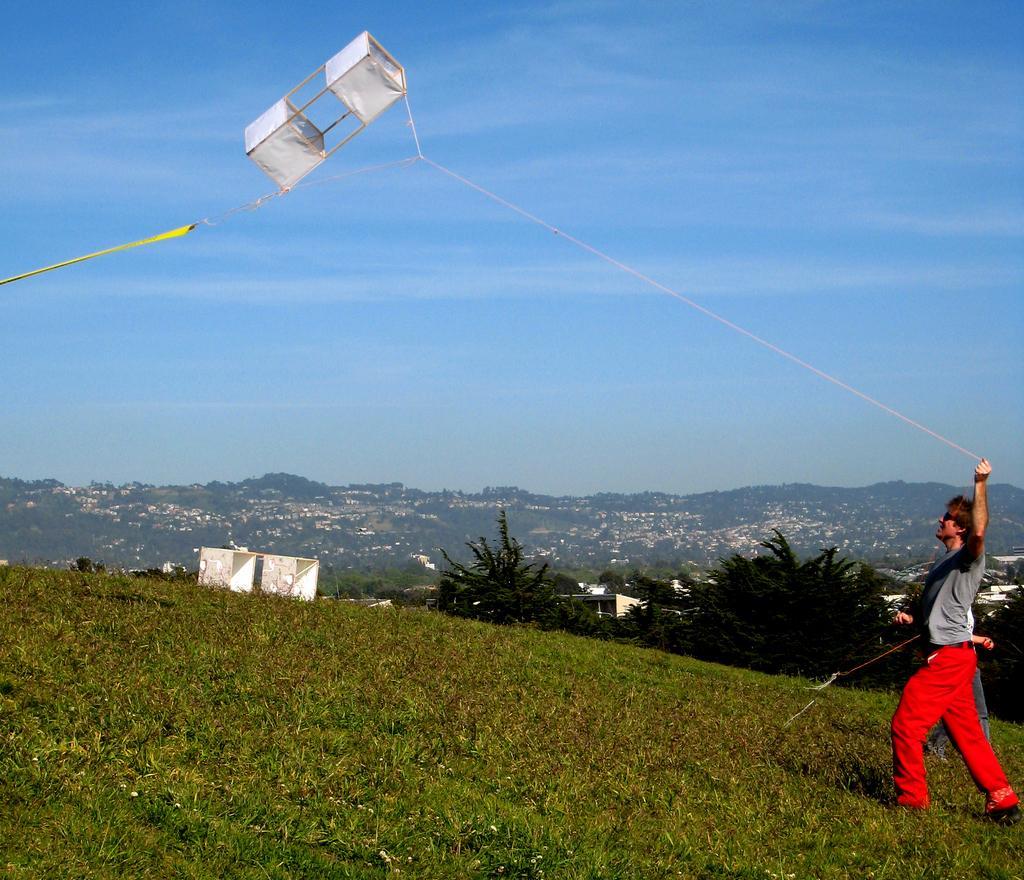Describe this image in one or two sentences. In this picture we can see two persons walking on the ground where a person holding a thread with his hand and in the background we can see trees, hills, sky with clouds. 